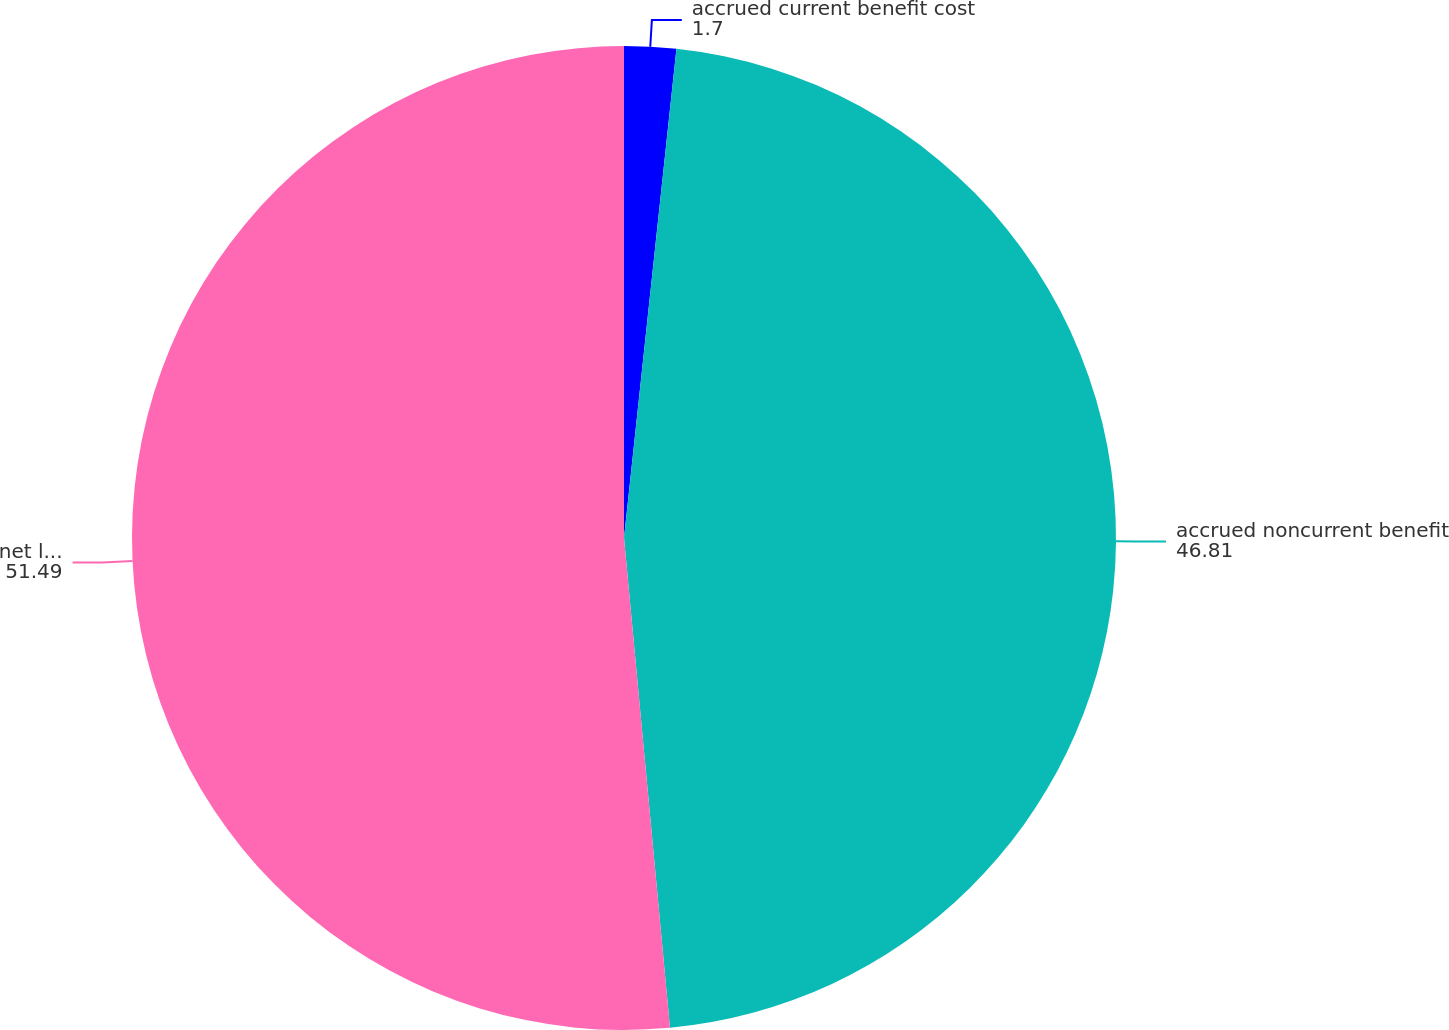<chart> <loc_0><loc_0><loc_500><loc_500><pie_chart><fcel>accrued current benefit cost<fcel>accrued noncurrent benefit<fcel>net liability recognized in<nl><fcel>1.7%<fcel>46.81%<fcel>51.49%<nl></chart> 